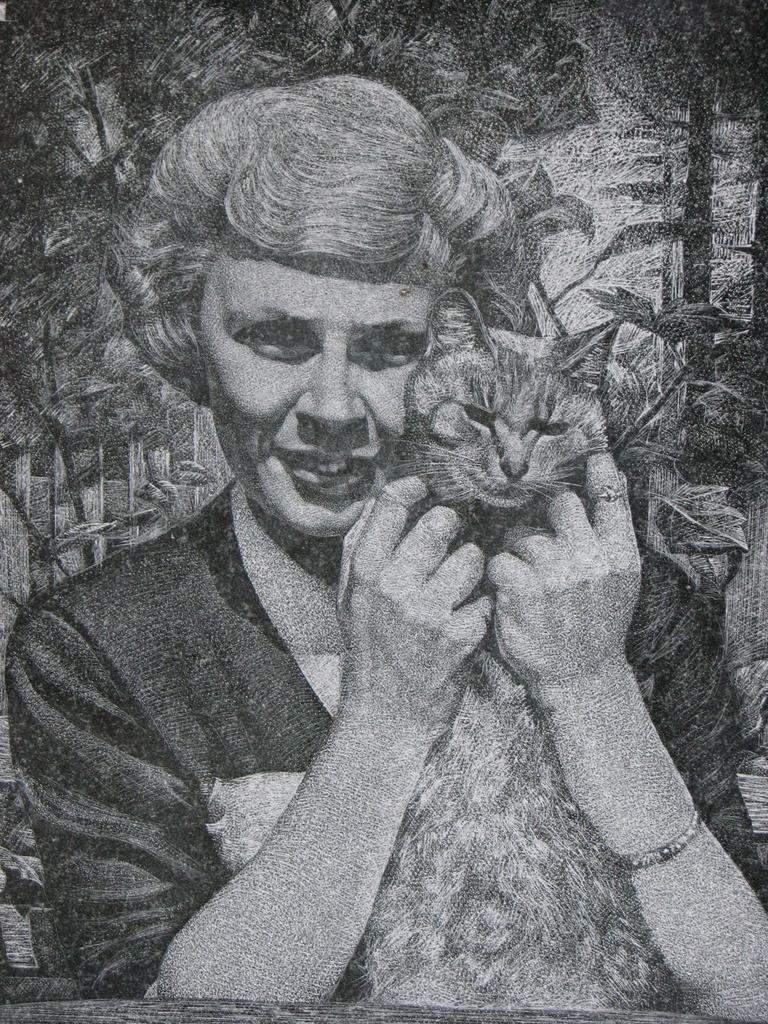What type of art piece is in the image? The image contains a black and white art piece. What is the subject of the art piece? The art piece depicts a woman. What is the woman holding in the art piece? The woman is holding a cat. What type of leather material is visible in the image? There is no leather material present in the image. What color paint is being used by the woman in the image? The image is black and white, so it is not possible to determine the color of any paint being used. 